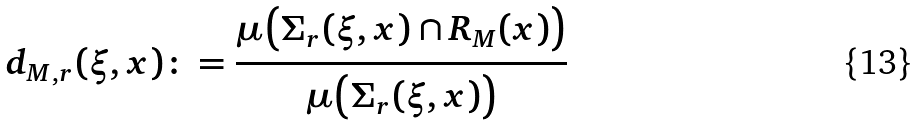Convert formula to latex. <formula><loc_0><loc_0><loc_500><loc_500>d _ { M , r } ( \xi , x ) \colon = \frac { \mu \left ( \Sigma _ { r } ( \xi , x ) \cap R _ { M } ( x ) \right ) } { \mu \left ( \Sigma _ { r } ( \xi , x ) \right ) }</formula> 